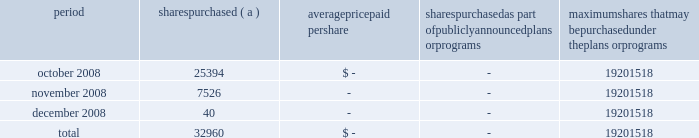Annual report on form 10-k 108 fifth third bancorp part ii item 5 .
Market for registrant 2019s common equity , related stockholder matters and issuer purchases of equity securities the information required by this item is included in the corporate information found on the inside of the back cover and in the discussion of dividend limitations that the subsidiaries can pay to the bancorp discussed in note 26 of the notes to the consolidated financial statements .
Additionally , as of december 31 , 2008 , the bancorp had approximately 60025 shareholders of record .
Issuer purchases of equity securities period shares purchased average paid per shares purchased as part of publicly announced plans or programs maximum shares that may be purchased under the plans or programs .
( a ) the bancorp repurchased 25394 , 7526 and 40 shares during october , november and december of 2008 in connection with various employee compensation plans of the bancorp .
These purchases are not included against the maximum number of shares that may yet be purchased under the board of directors authorization. .
What portion of the total purchased shares presented in the table was purchased during october 2008? 
Computations: (25394 / 32960)
Answer: 0.77045. 